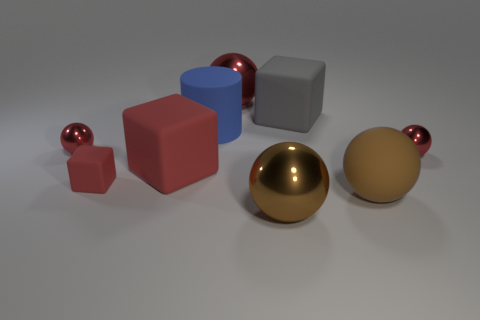Subtract all green cylinders. How many red spheres are left? 3 Subtract all cyan cubes. Subtract all cyan balls. How many cubes are left? 3 Subtract all spheres. How many objects are left? 4 Add 6 gray matte things. How many gray matte things are left? 7 Add 1 small yellow blocks. How many small yellow blocks exist? 1 Subtract 1 gray cubes. How many objects are left? 8 Subtract all green matte cubes. Subtract all brown rubber objects. How many objects are left? 8 